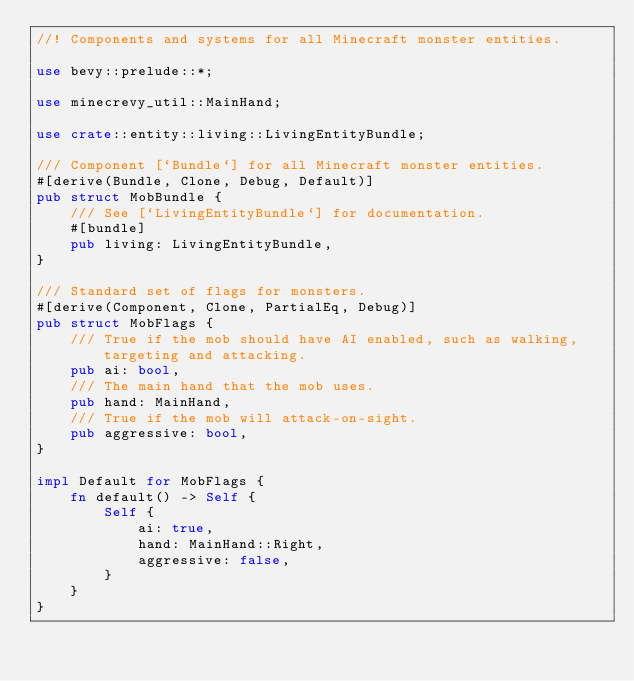Convert code to text. <code><loc_0><loc_0><loc_500><loc_500><_Rust_>//! Components and systems for all Minecraft monster entities.

use bevy::prelude::*;

use minecrevy_util::MainHand;

use crate::entity::living::LivingEntityBundle;

/// Component [`Bundle`] for all Minecraft monster entities.
#[derive(Bundle, Clone, Debug, Default)]
pub struct MobBundle {
    /// See [`LivingEntityBundle`] for documentation.
    #[bundle]
    pub living: LivingEntityBundle,
}

/// Standard set of flags for monsters.
#[derive(Component, Clone, PartialEq, Debug)]
pub struct MobFlags {
    /// True if the mob should have AI enabled, such as walking, targeting and attacking.
    pub ai: bool,
    /// The main hand that the mob uses.
    pub hand: MainHand,
    /// True if the mob will attack-on-sight.
    pub aggressive: bool,
}

impl Default for MobFlags {
    fn default() -> Self {
        Self {
            ai: true,
            hand: MainHand::Right,
            aggressive: false,
        }
    }
}
</code> 